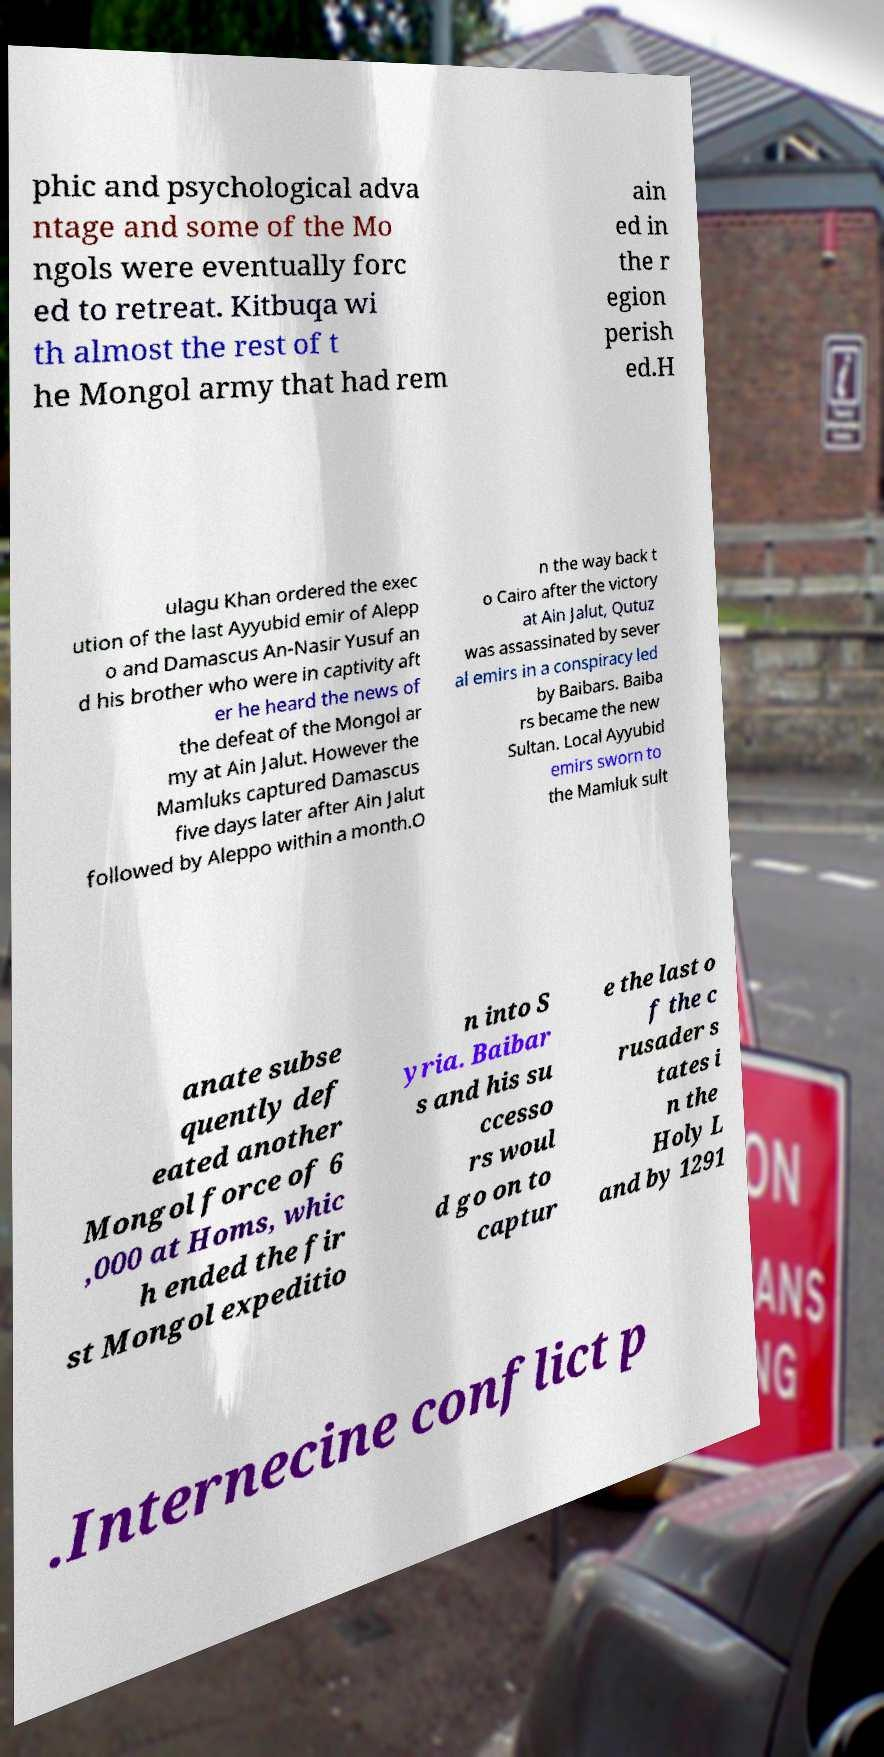Please identify and transcribe the text found in this image. phic and psychological adva ntage and some of the Mo ngols were eventually forc ed to retreat. Kitbuqa wi th almost the rest of t he Mongol army that had rem ain ed in the r egion perish ed.H ulagu Khan ordered the exec ution of the last Ayyubid emir of Alepp o and Damascus An-Nasir Yusuf an d his brother who were in captivity aft er he heard the news of the defeat of the Mongol ar my at Ain Jalut. However the Mamluks captured Damascus five days later after Ain Jalut followed by Aleppo within a month.O n the way back t o Cairo after the victory at Ain Jalut, Qutuz was assassinated by sever al emirs in a conspiracy led by Baibars. Baiba rs became the new Sultan. Local Ayyubid emirs sworn to the Mamluk sult anate subse quently def eated another Mongol force of 6 ,000 at Homs, whic h ended the fir st Mongol expeditio n into S yria. Baibar s and his su ccesso rs woul d go on to captur e the last o f the c rusader s tates i n the Holy L and by 1291 .Internecine conflict p 